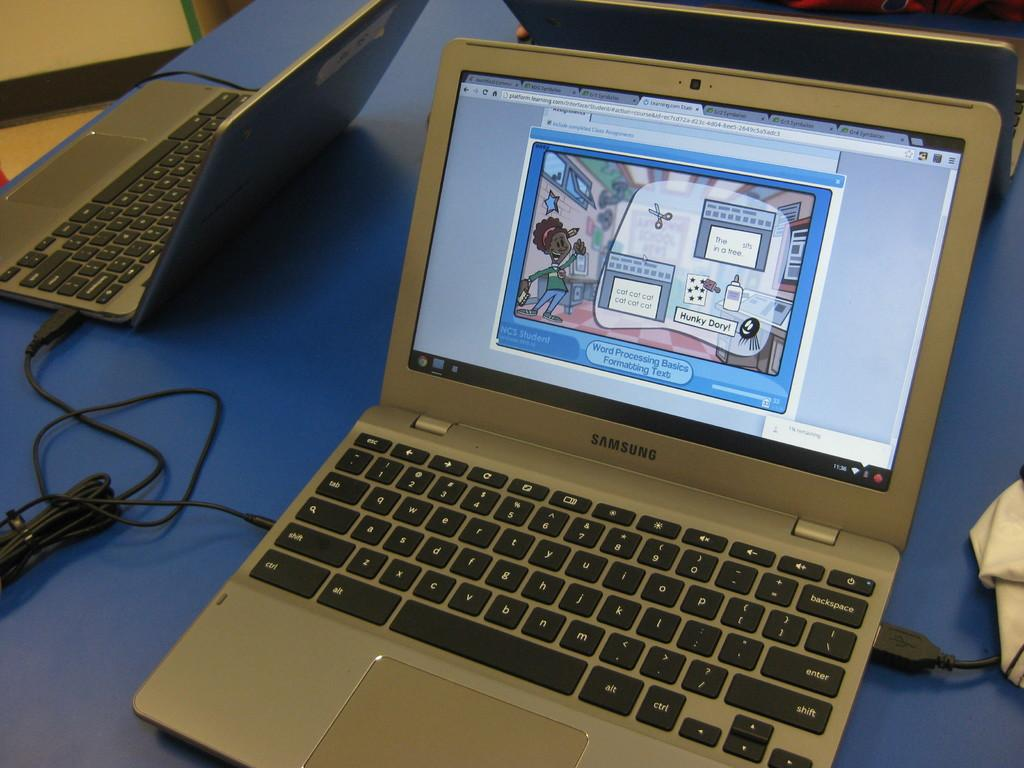Provide a one-sentence caption for the provided image. a silver laptop that is labeled as a samsung on it. 